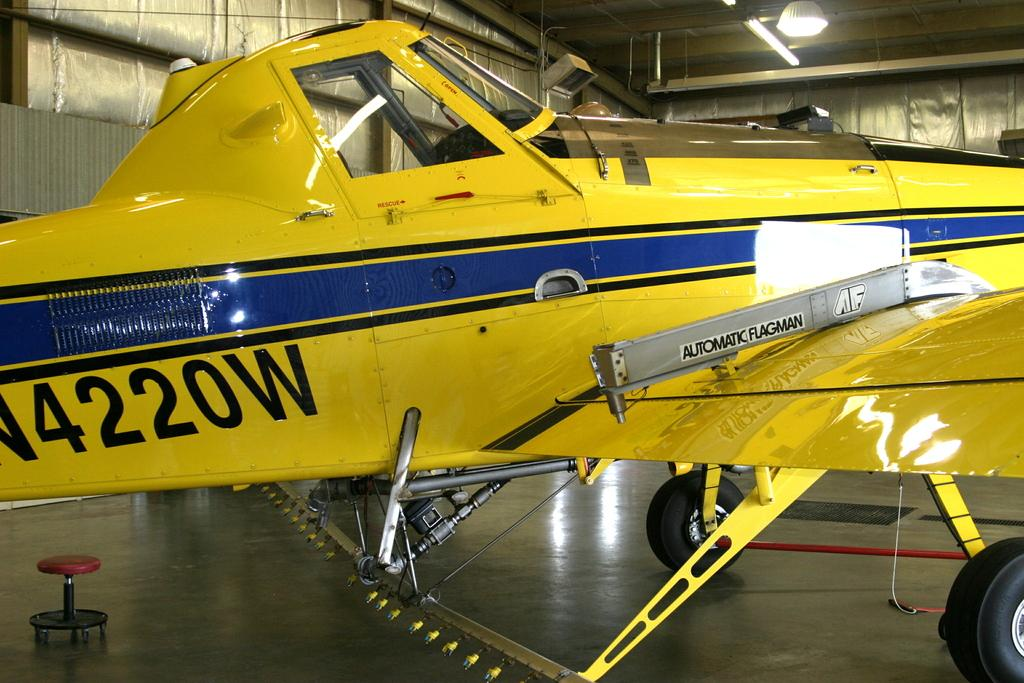<image>
Provide a brief description of the given image. A  yellow airplane is parked in a building with a number on it that ends with the letter w. 